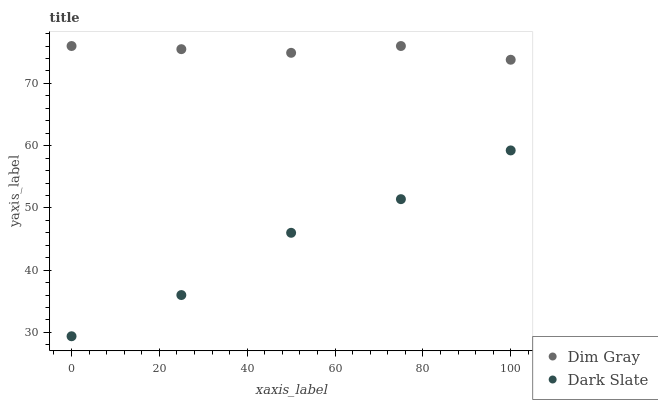Does Dark Slate have the minimum area under the curve?
Answer yes or no. Yes. Does Dim Gray have the maximum area under the curve?
Answer yes or no. Yes. Does Dim Gray have the minimum area under the curve?
Answer yes or no. No. Is Dim Gray the smoothest?
Answer yes or no. Yes. Is Dark Slate the roughest?
Answer yes or no. Yes. Is Dim Gray the roughest?
Answer yes or no. No. Does Dark Slate have the lowest value?
Answer yes or no. Yes. Does Dim Gray have the lowest value?
Answer yes or no. No. Does Dim Gray have the highest value?
Answer yes or no. Yes. Is Dark Slate less than Dim Gray?
Answer yes or no. Yes. Is Dim Gray greater than Dark Slate?
Answer yes or no. Yes. Does Dark Slate intersect Dim Gray?
Answer yes or no. No. 